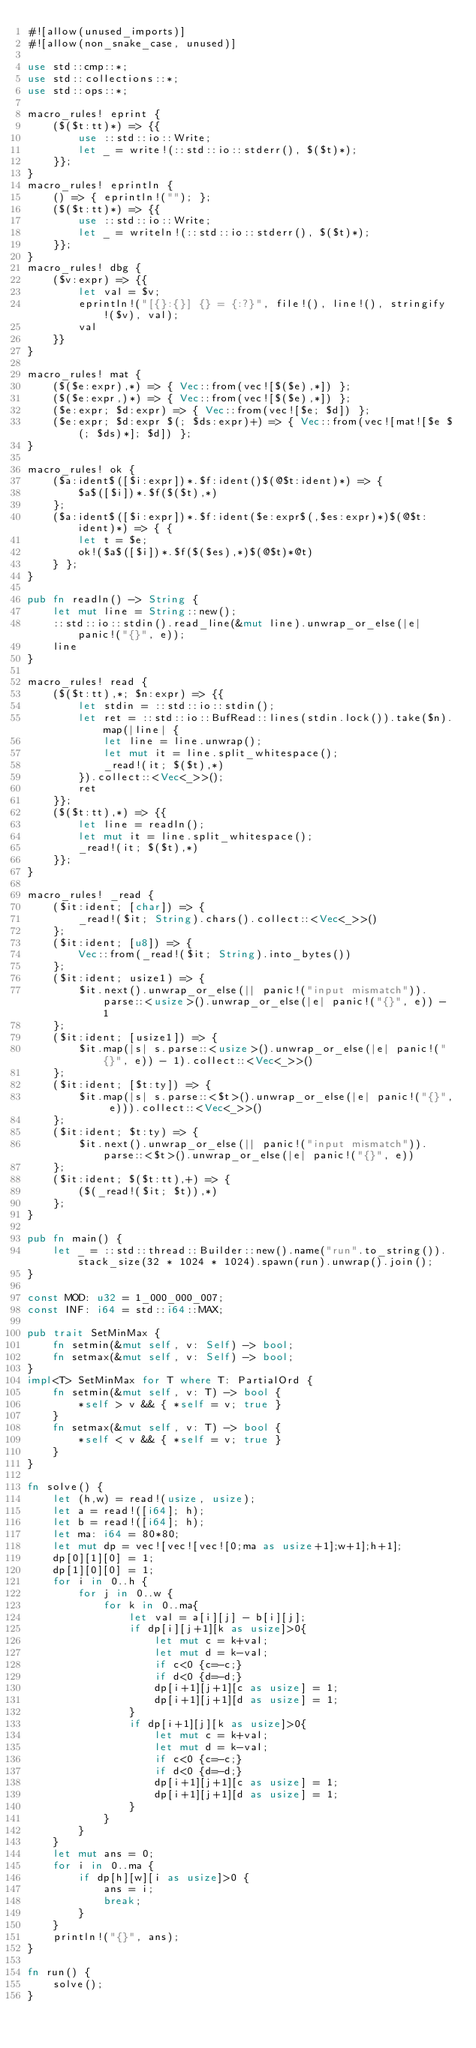Convert code to text. <code><loc_0><loc_0><loc_500><loc_500><_Rust_>#![allow(unused_imports)]
#![allow(non_snake_case, unused)]

use std::cmp::*;
use std::collections::*;
use std::ops::*;

macro_rules! eprint {
	($($t:tt)*) => {{
		use ::std::io::Write;
		let _ = write!(::std::io::stderr(), $($t)*);
	}};
}
macro_rules! eprintln {
	() => { eprintln!(""); };
	($($t:tt)*) => {{
		use ::std::io::Write;
		let _ = writeln!(::std::io::stderr(), $($t)*);
	}};
}
macro_rules! dbg {
	($v:expr) => {{
		let val = $v;
		eprintln!("[{}:{}] {} = {:?}", file!(), line!(), stringify!($v), val);
		val
	}}
}

macro_rules! mat {
	($($e:expr),*) => { Vec::from(vec![$($e),*]) };
	($($e:expr,)*) => { Vec::from(vec![$($e),*]) };
	($e:expr; $d:expr) => { Vec::from(vec![$e; $d]) };
	($e:expr; $d:expr $(; $ds:expr)+) => { Vec::from(vec![mat![$e $(; $ds)*]; $d]) };
}

macro_rules! ok {
	($a:ident$([$i:expr])*.$f:ident()$(@$t:ident)*) => {
		$a$([$i])*.$f($($t),*)
	};
	($a:ident$([$i:expr])*.$f:ident($e:expr$(,$es:expr)*)$(@$t:ident)*) => { {
		let t = $e;
		ok!($a$([$i])*.$f($($es),*)$(@$t)*@t)
	} };
}

pub fn readln() -> String {
	let mut line = String::new();
	::std::io::stdin().read_line(&mut line).unwrap_or_else(|e| panic!("{}", e));
	line
}

macro_rules! read {
	($($t:tt),*; $n:expr) => {{
		let stdin = ::std::io::stdin();
		let ret = ::std::io::BufRead::lines(stdin.lock()).take($n).map(|line| {
			let line = line.unwrap();
			let mut it = line.split_whitespace();
			_read!(it; $($t),*)
		}).collect::<Vec<_>>();
		ret
	}};
	($($t:tt),*) => {{
		let line = readln();
		let mut it = line.split_whitespace();
		_read!(it; $($t),*)
	}};
}

macro_rules! _read {
	($it:ident; [char]) => {
		_read!($it; String).chars().collect::<Vec<_>>()
	};
	($it:ident; [u8]) => {
		Vec::from(_read!($it; String).into_bytes())
	};
	($it:ident; usize1) => {
		$it.next().unwrap_or_else(|| panic!("input mismatch")).parse::<usize>().unwrap_or_else(|e| panic!("{}", e)) - 1
	};
	($it:ident; [usize1]) => {
		$it.map(|s| s.parse::<usize>().unwrap_or_else(|e| panic!("{}", e)) - 1).collect::<Vec<_>>()
	};
	($it:ident; [$t:ty]) => {
		$it.map(|s| s.parse::<$t>().unwrap_or_else(|e| panic!("{}", e))).collect::<Vec<_>>()
	};
	($it:ident; $t:ty) => {
		$it.next().unwrap_or_else(|| panic!("input mismatch")).parse::<$t>().unwrap_or_else(|e| panic!("{}", e))
	};
	($it:ident; $($t:tt),+) => {
		($(_read!($it; $t)),*)
	};
}

pub fn main() {
	let _ = ::std::thread::Builder::new().name("run".to_string()).stack_size(32 * 1024 * 1024).spawn(run).unwrap().join();
}

const MOD: u32 = 1_000_000_007;
const INF: i64 = std::i64::MAX;

pub trait SetMinMax {
	fn setmin(&mut self, v: Self) -> bool;
	fn setmax(&mut self, v: Self) -> bool;
}
impl<T> SetMinMax for T where T: PartialOrd {
	fn setmin(&mut self, v: T) -> bool {
		*self > v && { *self = v; true }
	}
	fn setmax(&mut self, v: T) -> bool {
		*self < v && { *self = v; true }
	}
}

fn solve() {
	let (h,w) = read!(usize, usize);
	let a = read!([i64]; h);
	let b = read!([i64]; h);
	let ma: i64 = 80*80;
	let mut dp = vec![vec![vec![0;ma as usize+1];w+1];h+1];
	dp[0][1][0] = 1;
	dp[1][0][0] = 1;
	for i in 0..h {
		for j in 0..w {
			for k in 0..ma{
				let val = a[i][j] - b[i][j];
				if dp[i][j+1][k as usize]>0{
					let mut c = k+val;
					let mut d = k-val;
					if c<0 {c=-c;}
					if d<0 {d=-d;}
					dp[i+1][j+1][c as usize] = 1;
					dp[i+1][j+1][d as usize] = 1;
				}
				if dp[i+1][j][k as usize]>0{
					let mut c = k+val;
					let mut d = k-val;
					if c<0 {c=-c;}
					if d<0 {d=-d;}
					dp[i+1][j+1][c as usize] = 1;
					dp[i+1][j+1][d as usize] = 1;
				}
			}
		}
	}
	let mut ans = 0;
	for i in 0..ma {
		if dp[h][w][i as usize]>0 {
			ans = i;
			break;
		}
	}
	println!("{}", ans);
}

fn run() {
    solve();
}</code> 